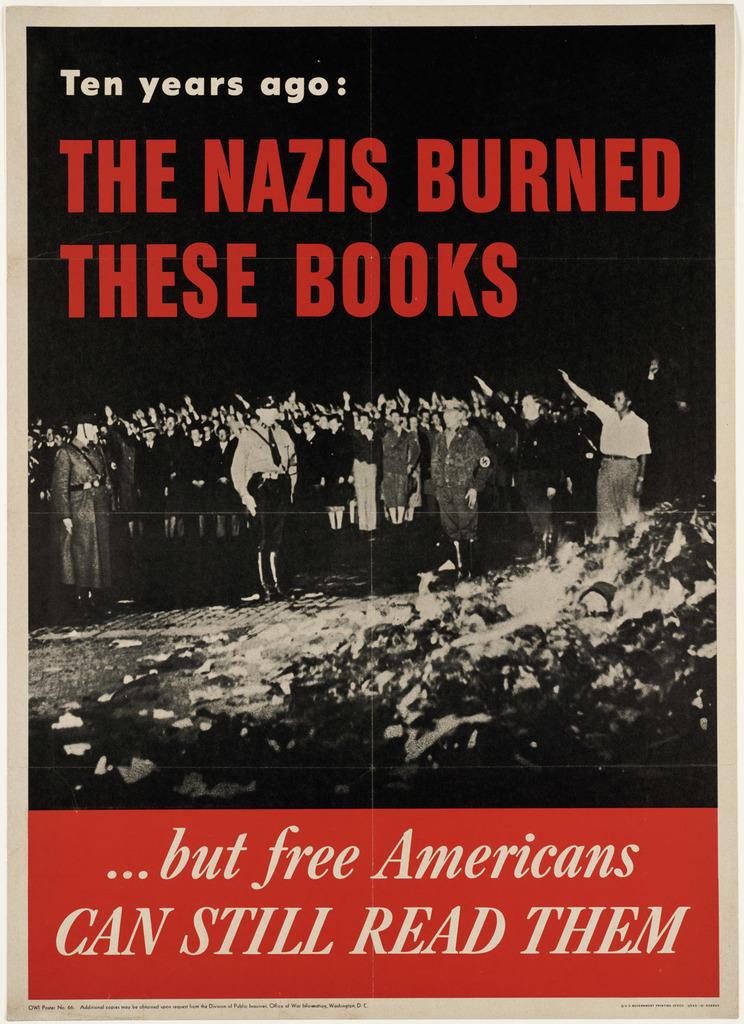What books did nazis burn?
Keep it short and to the point. These books. How many years ago does it say that nazis burned the books?
Your response must be concise. Ten. 